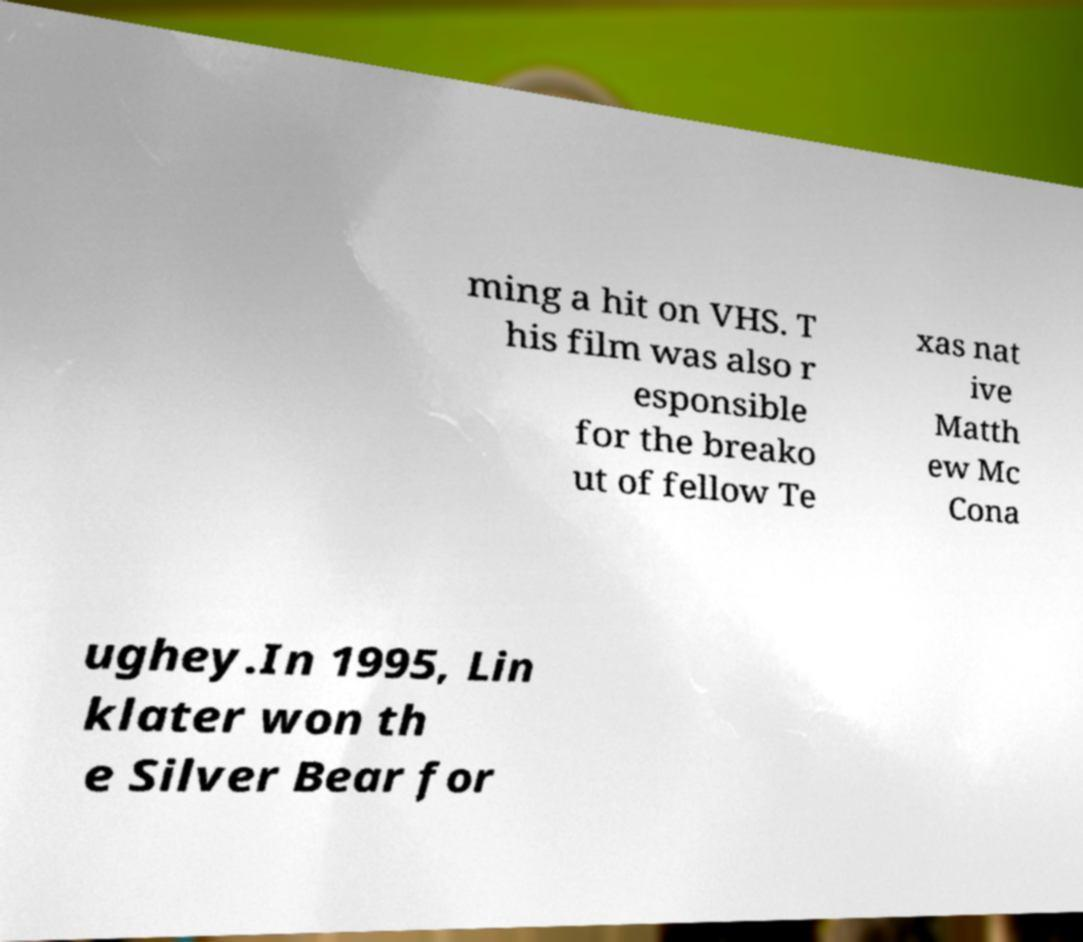Could you assist in decoding the text presented in this image and type it out clearly? ming a hit on VHS. T his film was also r esponsible for the breako ut of fellow Te xas nat ive Matth ew Mc Cona ughey.In 1995, Lin klater won th e Silver Bear for 